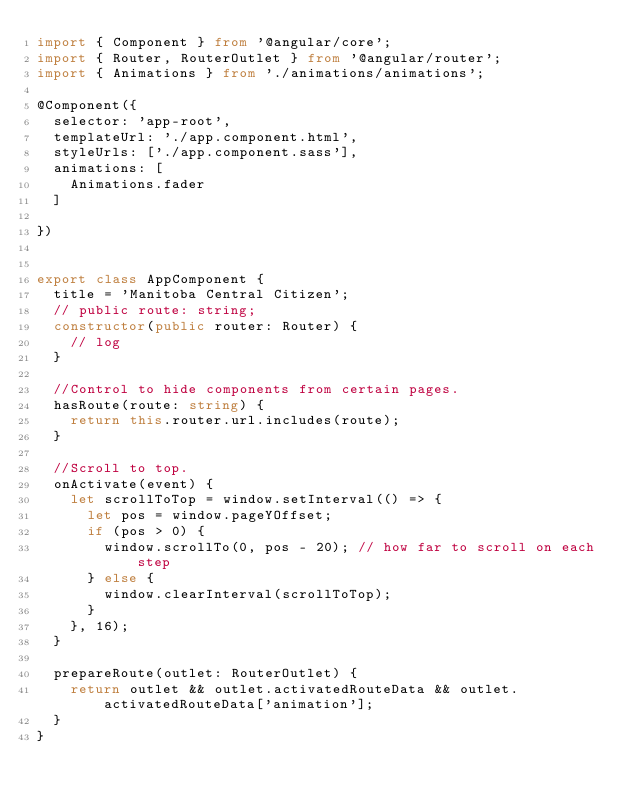Convert code to text. <code><loc_0><loc_0><loc_500><loc_500><_TypeScript_>import { Component } from '@angular/core';
import { Router, RouterOutlet } from '@angular/router';
import { Animations } from './animations/animations';

@Component({
  selector: 'app-root',
  templateUrl: './app.component.html',
  styleUrls: ['./app.component.sass'],
  animations: [
    Animations.fader
  ]

})


export class AppComponent {
  title = 'Manitoba Central Citizen';
  // public route: string;
  constructor(public router: Router) {
    // log
  }

  //Control to hide components from certain pages.
  hasRoute(route: string) {
    return this.router.url.includes(route);
  }

  //Scroll to top.
  onActivate(event) {
    let scrollToTop = window.setInterval(() => {
      let pos = window.pageYOffset;
      if (pos > 0) {
        window.scrollTo(0, pos - 20); // how far to scroll on each step
      } else {
        window.clearInterval(scrollToTop);
      }
    }, 16);
  }

  prepareRoute(outlet: RouterOutlet) {
    return outlet && outlet.activatedRouteData && outlet.activatedRouteData['animation'];
  }
}
</code> 